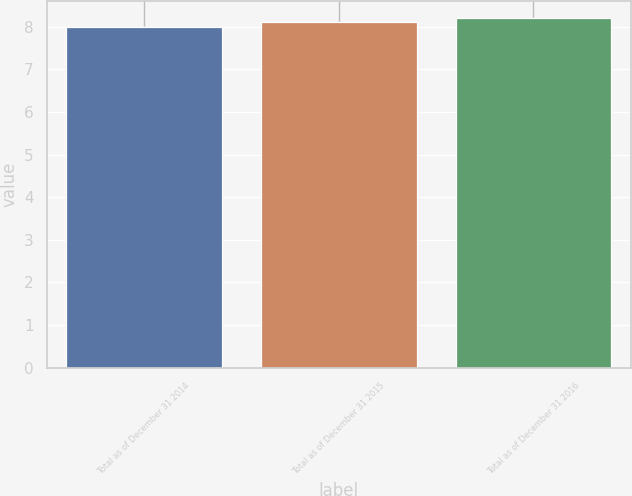<chart> <loc_0><loc_0><loc_500><loc_500><bar_chart><fcel>Total as of December 31 2014<fcel>Total as of December 31 2015<fcel>Total as of December 31 2016<nl><fcel>8<fcel>8.1<fcel>8.2<nl></chart> 